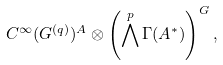<formula> <loc_0><loc_0><loc_500><loc_500>C ^ { \infty } ( G ^ { ( q ) } ) ^ { A } \otimes \left ( \bigwedge ^ { p } \Gamma ( A ^ { * } ) \right ) ^ { G } ,</formula> 